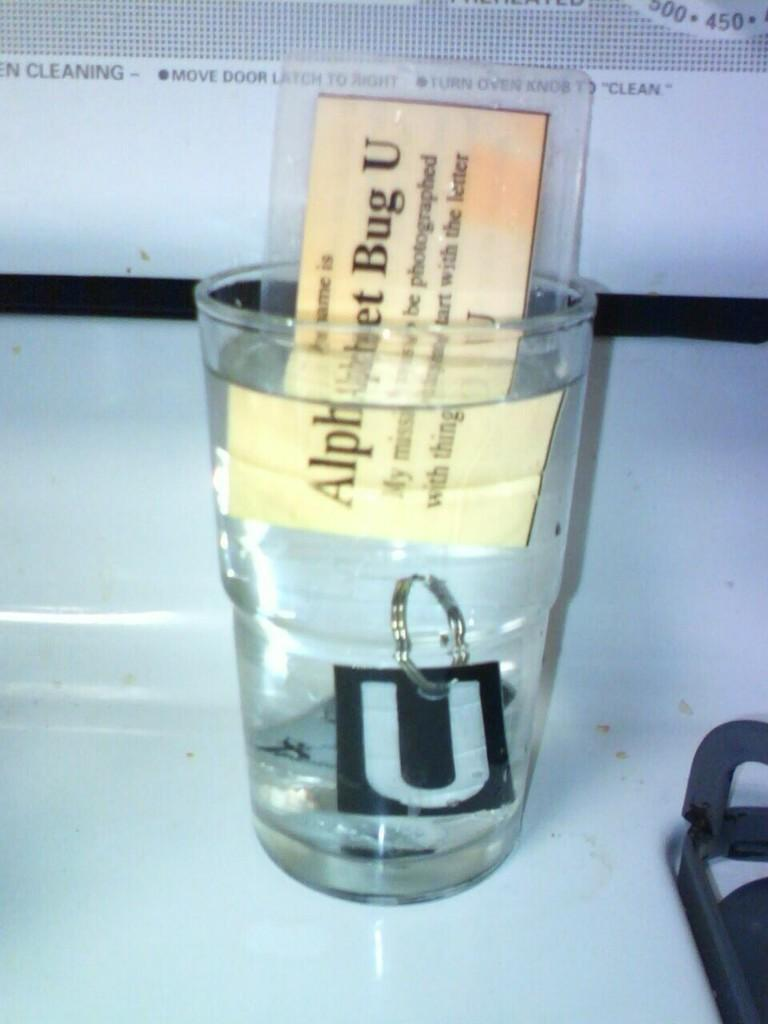<image>
Offer a succinct explanation of the picture presented. A clear glass has water and a card that says Alphabet Bug U in it. 